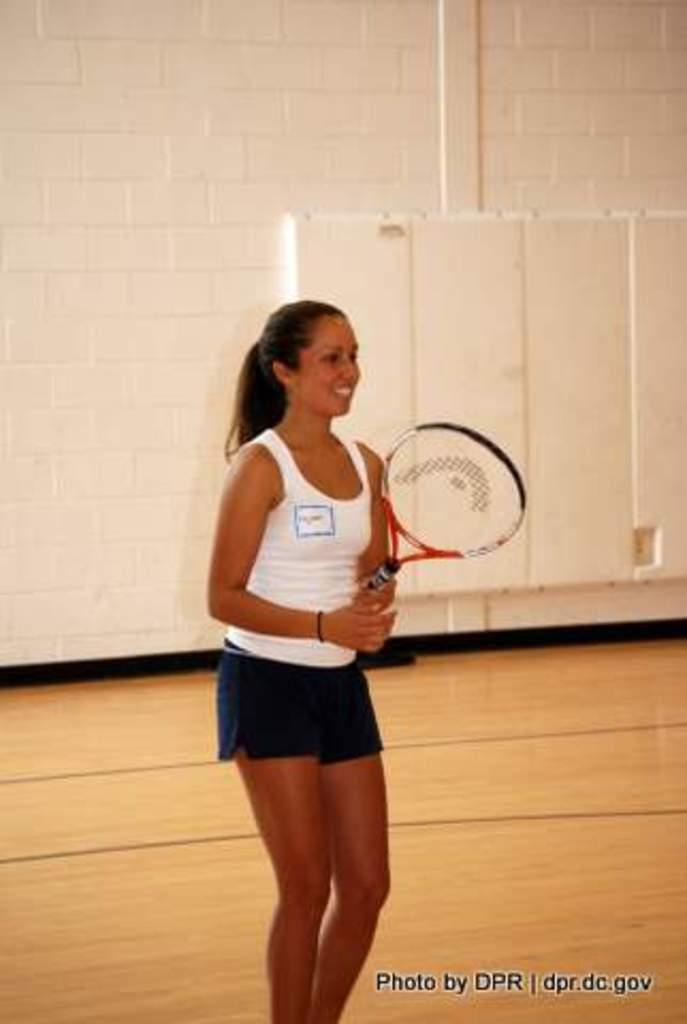What is the woman doing in the image? She is standing and smiling. What object is she holding in the image? She is holding a bat. What color is the wall in the background of the image? The wall in the background is white. How many chairs are visible in the image? There are no chairs present in the image. What type of shop can be seen in the background of the image? There is no shop visible in the image; it features a white wall in the background. 